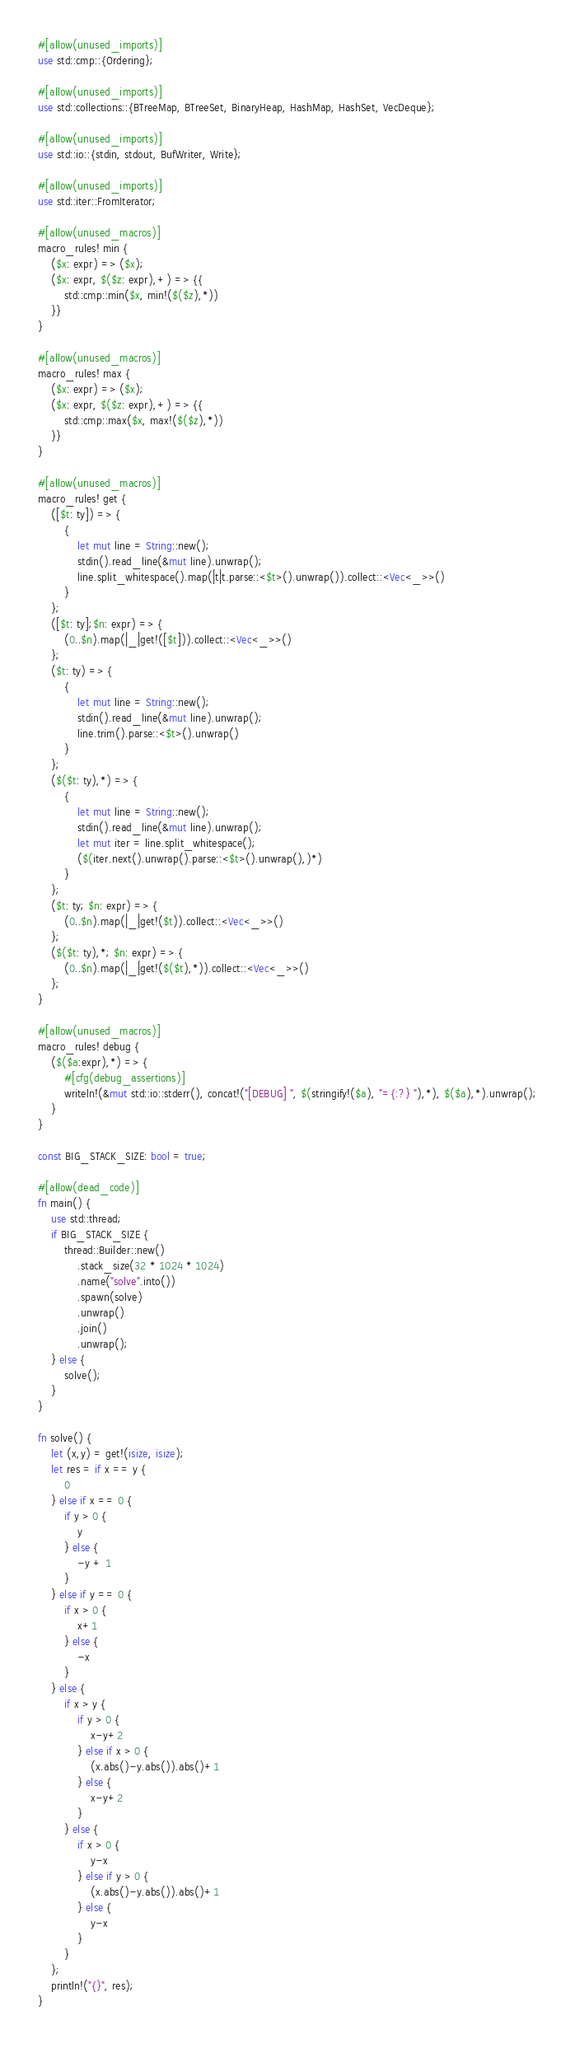Convert code to text. <code><loc_0><loc_0><loc_500><loc_500><_Rust_>#[allow(unused_imports)]
use std::cmp::{Ordering};

#[allow(unused_imports)]
use std::collections::{BTreeMap, BTreeSet, BinaryHeap, HashMap, HashSet, VecDeque};

#[allow(unused_imports)]
use std::io::{stdin, stdout, BufWriter, Write};

#[allow(unused_imports)]
use std::iter::FromIterator;

#[allow(unused_macros)]
macro_rules! min {
    ($x: expr) => ($x);
    ($x: expr, $($z: expr),+) => {{
        std::cmp::min($x, min!($($z),*))
    }}
}

#[allow(unused_macros)]
macro_rules! max {
    ($x: expr) => ($x);
    ($x: expr, $($z: expr),+) => {{
        std::cmp::max($x, max!($($z),*))
    }}
}

#[allow(unused_macros)]
macro_rules! get { 
    ([$t: ty]) => { 
        { 
            let mut line = String::new(); 
            stdin().read_line(&mut line).unwrap(); 
            line.split_whitespace().map(|t|t.parse::<$t>().unwrap()).collect::<Vec<_>>()
        }
    };
    ([$t: ty];$n: expr) => {
        (0..$n).map(|_|get!([$t])).collect::<Vec<_>>()
    };
    ($t: ty) => {
        {
            let mut line = String::new();
            stdin().read_line(&mut line).unwrap();
            line.trim().parse::<$t>().unwrap()
        }
    };
    ($($t: ty),*) => {
        { 
            let mut line = String::new();
            stdin().read_line(&mut line).unwrap();
            let mut iter = line.split_whitespace();
            ($(iter.next().unwrap().parse::<$t>().unwrap(),)*)
        }
    };
    ($t: ty; $n: expr) => {
        (0..$n).map(|_|get!($t)).collect::<Vec<_>>()
    };
    ($($t: ty),*; $n: expr) => {
        (0..$n).map(|_|get!($($t),*)).collect::<Vec<_>>()
    };
}

#[allow(unused_macros)]
macro_rules! debug {
    ($($a:expr),*) => {
        #[cfg(debug_assertions)]
        writeln!(&mut std::io::stderr(), concat!("[DEBUG] ", $(stringify!($a), "={:?} "),*), $($a),*).unwrap();
    }
}

const BIG_STACK_SIZE: bool = true;

#[allow(dead_code)]
fn main() {
    use std::thread;
    if BIG_STACK_SIZE {
        thread::Builder::new()
            .stack_size(32 * 1024 * 1024)
            .name("solve".into())
            .spawn(solve)
            .unwrap()
            .join()
            .unwrap();
    } else {
        solve();
    }
}

fn solve() {
    let (x,y) = get!(isize, isize);
    let res = if x == y {
        0
    } else if x == 0 {
        if y > 0 {
            y
        } else {
            -y + 1
        }
    } else if y == 0 {
        if x > 0 {
            x+1
        } else {
            -x
        }
    } else {
        if x > y {
            if y > 0 {
                x-y+2
            } else if x > 0 {
                (x.abs()-y.abs()).abs()+1
            } else {
                x-y+2
            }
        } else {
            if x > 0 {
                y-x
            } else if y > 0 {
                (x.abs()-y.abs()).abs()+1
            } else {
                y-x
            }
        }
    };
    println!("{}", res);
}
</code> 